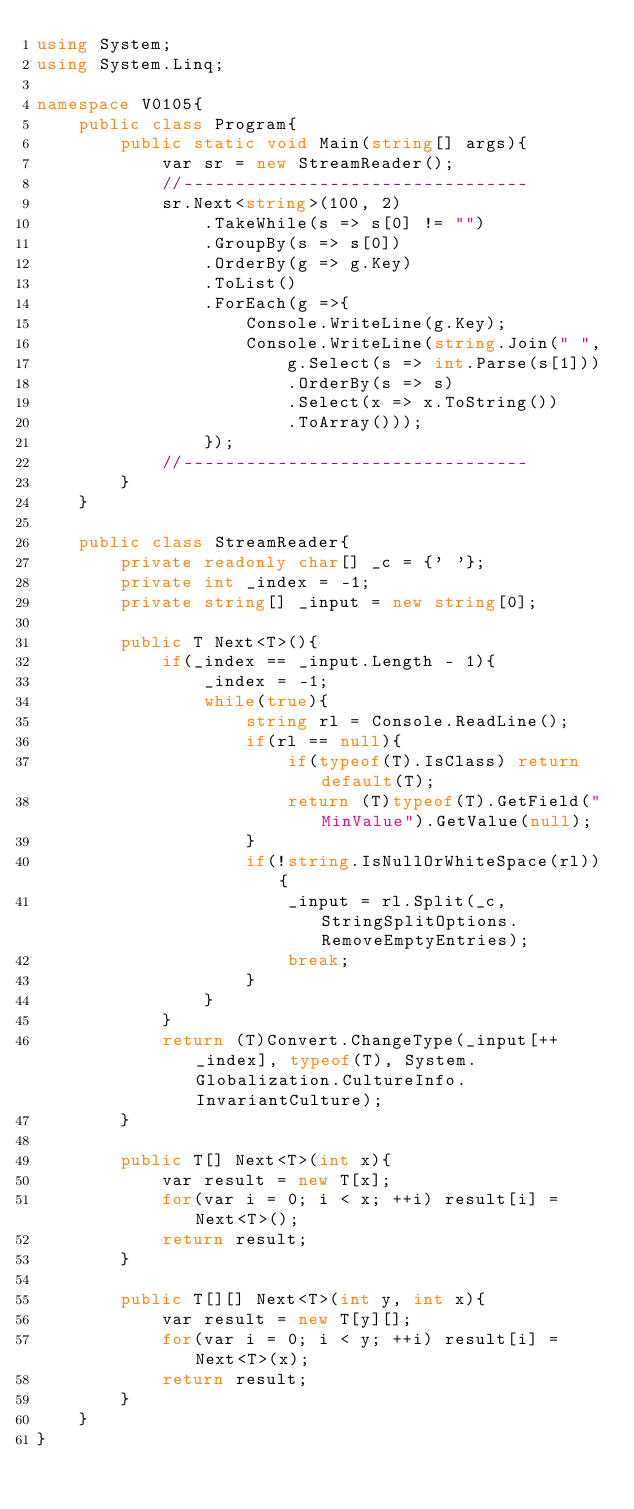Convert code to text. <code><loc_0><loc_0><loc_500><loc_500><_C#_>using System;
using System.Linq;

namespace V0105{
    public class Program{
        public static void Main(string[] args){
            var sr = new StreamReader();
            //---------------------------------
            sr.Next<string>(100, 2)
                .TakeWhile(s => s[0] != "")
                .GroupBy(s => s[0])
                .OrderBy(g => g.Key)
                .ToList()
                .ForEach(g =>{
                    Console.WriteLine(g.Key);
                    Console.WriteLine(string.Join(" ",
                        g.Select(s => int.Parse(s[1]))
                        .OrderBy(s => s)
                        .Select(x => x.ToString())
                        .ToArray()));
                });
            //---------------------------------
        }
    }

    public class StreamReader{
        private readonly char[] _c = {' '};
        private int _index = -1;
        private string[] _input = new string[0];

        public T Next<T>(){
            if(_index == _input.Length - 1){
                _index = -1;
                while(true){
                    string rl = Console.ReadLine();
                    if(rl == null){
                        if(typeof(T).IsClass) return default(T);
                        return (T)typeof(T).GetField("MinValue").GetValue(null);
                    }
                    if(!string.IsNullOrWhiteSpace(rl)){
                        _input = rl.Split(_c, StringSplitOptions.RemoveEmptyEntries);
                        break;
                    }
                }
            }
            return (T)Convert.ChangeType(_input[++_index], typeof(T), System.Globalization.CultureInfo.InvariantCulture);
        }

        public T[] Next<T>(int x){
            var result = new T[x];
            for(var i = 0; i < x; ++i) result[i] = Next<T>();
            return result;
        }

        public T[][] Next<T>(int y, int x){
            var result = new T[y][];
            for(var i = 0; i < y; ++i) result[i] = Next<T>(x);
            return result;
        }
    }
}</code> 